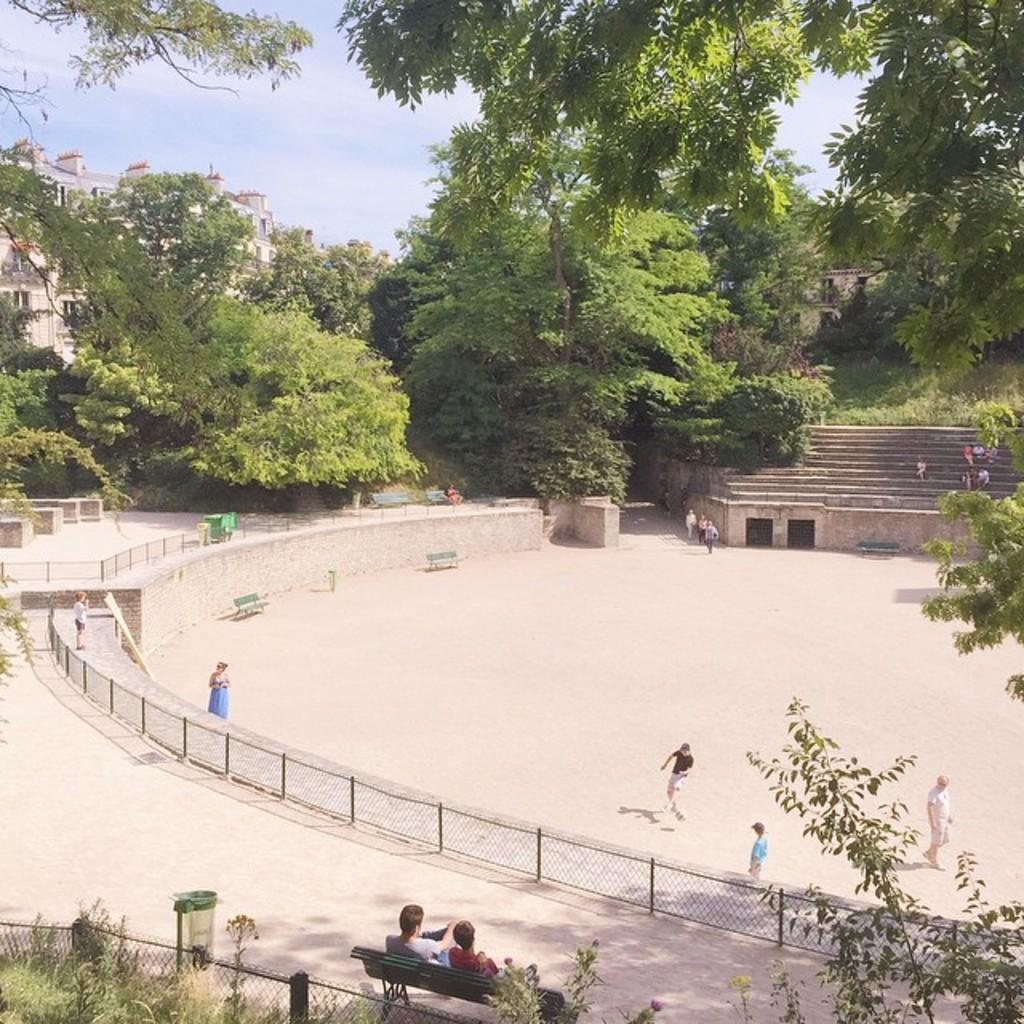How many persons are in the image? There are persons in the image, but the exact number is not specified. What are some of the persons doing in the image? Some of the persons are walking, and some are sitting. What type of vegetation can be seen in the image? There are trees in the image, and they are green. What type of structure is present in the image? There is a building in the image, and it is cream-colored. What is visible in the sky in the image? The sky is visible in the image, and it has white and blue colors. What type of system can be seen in the image? There is no system present in the image; it features persons, trees, a building, and the sky. What type of curve is visible in the image? There is no curve visible in the image. 